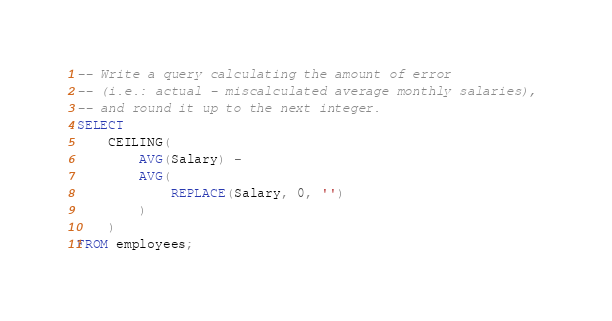<code> <loc_0><loc_0><loc_500><loc_500><_SQL_>-- Write a query calculating the amount of error 
-- (i.e.: actual - miscalculated average monthly salaries), 
-- and round it up to the next integer.
SELECT 
    CEILING(
        AVG(Salary) - 
        AVG(
            REPLACE(Salary, 0, '')
        )
    ) 
FROM employees;
</code> 